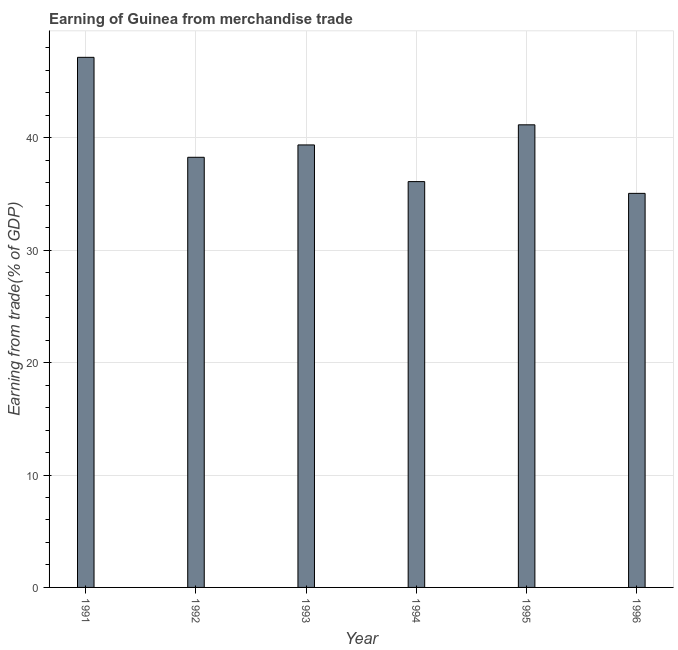Does the graph contain any zero values?
Provide a succinct answer. No. What is the title of the graph?
Provide a succinct answer. Earning of Guinea from merchandise trade. What is the label or title of the X-axis?
Offer a terse response. Year. What is the label or title of the Y-axis?
Give a very brief answer. Earning from trade(% of GDP). What is the earning from merchandise trade in 1991?
Offer a very short reply. 47.17. Across all years, what is the maximum earning from merchandise trade?
Keep it short and to the point. 47.17. Across all years, what is the minimum earning from merchandise trade?
Offer a very short reply. 35.06. In which year was the earning from merchandise trade maximum?
Your answer should be compact. 1991. What is the sum of the earning from merchandise trade?
Offer a terse response. 237.16. What is the difference between the earning from merchandise trade in 1991 and 1994?
Keep it short and to the point. 11.06. What is the average earning from merchandise trade per year?
Keep it short and to the point. 39.53. What is the median earning from merchandise trade?
Your answer should be compact. 38.82. Do a majority of the years between 1992 and 1995 (inclusive) have earning from merchandise trade greater than 16 %?
Offer a terse response. Yes. Is the difference between the earning from merchandise trade in 1993 and 1996 greater than the difference between any two years?
Your answer should be compact. No. What is the difference between the highest and the second highest earning from merchandise trade?
Give a very brief answer. 6. Is the sum of the earning from merchandise trade in 1991 and 1994 greater than the maximum earning from merchandise trade across all years?
Your response must be concise. Yes. Are all the bars in the graph horizontal?
Make the answer very short. No. Are the values on the major ticks of Y-axis written in scientific E-notation?
Your answer should be very brief. No. What is the Earning from trade(% of GDP) in 1991?
Provide a short and direct response. 47.17. What is the Earning from trade(% of GDP) of 1992?
Keep it short and to the point. 38.28. What is the Earning from trade(% of GDP) of 1993?
Provide a short and direct response. 39.37. What is the Earning from trade(% of GDP) in 1994?
Your answer should be very brief. 36.11. What is the Earning from trade(% of GDP) in 1995?
Make the answer very short. 41.16. What is the Earning from trade(% of GDP) of 1996?
Provide a succinct answer. 35.06. What is the difference between the Earning from trade(% of GDP) in 1991 and 1992?
Your response must be concise. 8.89. What is the difference between the Earning from trade(% of GDP) in 1991 and 1993?
Ensure brevity in your answer.  7.8. What is the difference between the Earning from trade(% of GDP) in 1991 and 1994?
Offer a very short reply. 11.06. What is the difference between the Earning from trade(% of GDP) in 1991 and 1995?
Offer a very short reply. 6. What is the difference between the Earning from trade(% of GDP) in 1991 and 1996?
Make the answer very short. 12.1. What is the difference between the Earning from trade(% of GDP) in 1992 and 1993?
Give a very brief answer. -1.1. What is the difference between the Earning from trade(% of GDP) in 1992 and 1994?
Offer a very short reply. 2.16. What is the difference between the Earning from trade(% of GDP) in 1992 and 1995?
Provide a succinct answer. -2.89. What is the difference between the Earning from trade(% of GDP) in 1992 and 1996?
Give a very brief answer. 3.21. What is the difference between the Earning from trade(% of GDP) in 1993 and 1994?
Offer a terse response. 3.26. What is the difference between the Earning from trade(% of GDP) in 1993 and 1995?
Give a very brief answer. -1.79. What is the difference between the Earning from trade(% of GDP) in 1993 and 1996?
Offer a terse response. 4.31. What is the difference between the Earning from trade(% of GDP) in 1994 and 1995?
Offer a terse response. -5.05. What is the difference between the Earning from trade(% of GDP) in 1994 and 1996?
Provide a succinct answer. 1.05. What is the difference between the Earning from trade(% of GDP) in 1995 and 1996?
Make the answer very short. 6.1. What is the ratio of the Earning from trade(% of GDP) in 1991 to that in 1992?
Make the answer very short. 1.23. What is the ratio of the Earning from trade(% of GDP) in 1991 to that in 1993?
Your response must be concise. 1.2. What is the ratio of the Earning from trade(% of GDP) in 1991 to that in 1994?
Your response must be concise. 1.31. What is the ratio of the Earning from trade(% of GDP) in 1991 to that in 1995?
Provide a succinct answer. 1.15. What is the ratio of the Earning from trade(% of GDP) in 1991 to that in 1996?
Give a very brief answer. 1.34. What is the ratio of the Earning from trade(% of GDP) in 1992 to that in 1994?
Your response must be concise. 1.06. What is the ratio of the Earning from trade(% of GDP) in 1992 to that in 1996?
Keep it short and to the point. 1.09. What is the ratio of the Earning from trade(% of GDP) in 1993 to that in 1994?
Your answer should be very brief. 1.09. What is the ratio of the Earning from trade(% of GDP) in 1993 to that in 1995?
Your response must be concise. 0.96. What is the ratio of the Earning from trade(% of GDP) in 1993 to that in 1996?
Give a very brief answer. 1.12. What is the ratio of the Earning from trade(% of GDP) in 1994 to that in 1995?
Your answer should be very brief. 0.88. What is the ratio of the Earning from trade(% of GDP) in 1994 to that in 1996?
Offer a very short reply. 1.03. What is the ratio of the Earning from trade(% of GDP) in 1995 to that in 1996?
Ensure brevity in your answer.  1.17. 